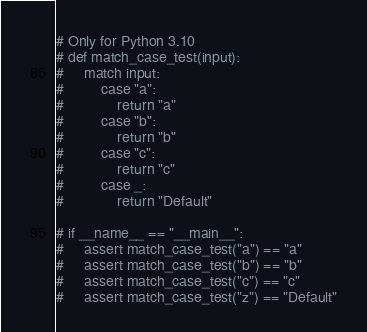<code> <loc_0><loc_0><loc_500><loc_500><_Python_>
# Only for Python 3.10
# def match_case_test(input):
#     match input:
#         case "a": 
#             return "a"
#         case "b":
#             return "b"
#         case "c":
#             return "c"
#         case _: 
#             return "Default"

# if __name__ == "__main__":
#     assert match_case_test("a") == "a"
#     assert match_case_test("b") == "b"
#     assert match_case_test("c") == "c"
#     assert match_case_test("z") == "Default"</code> 